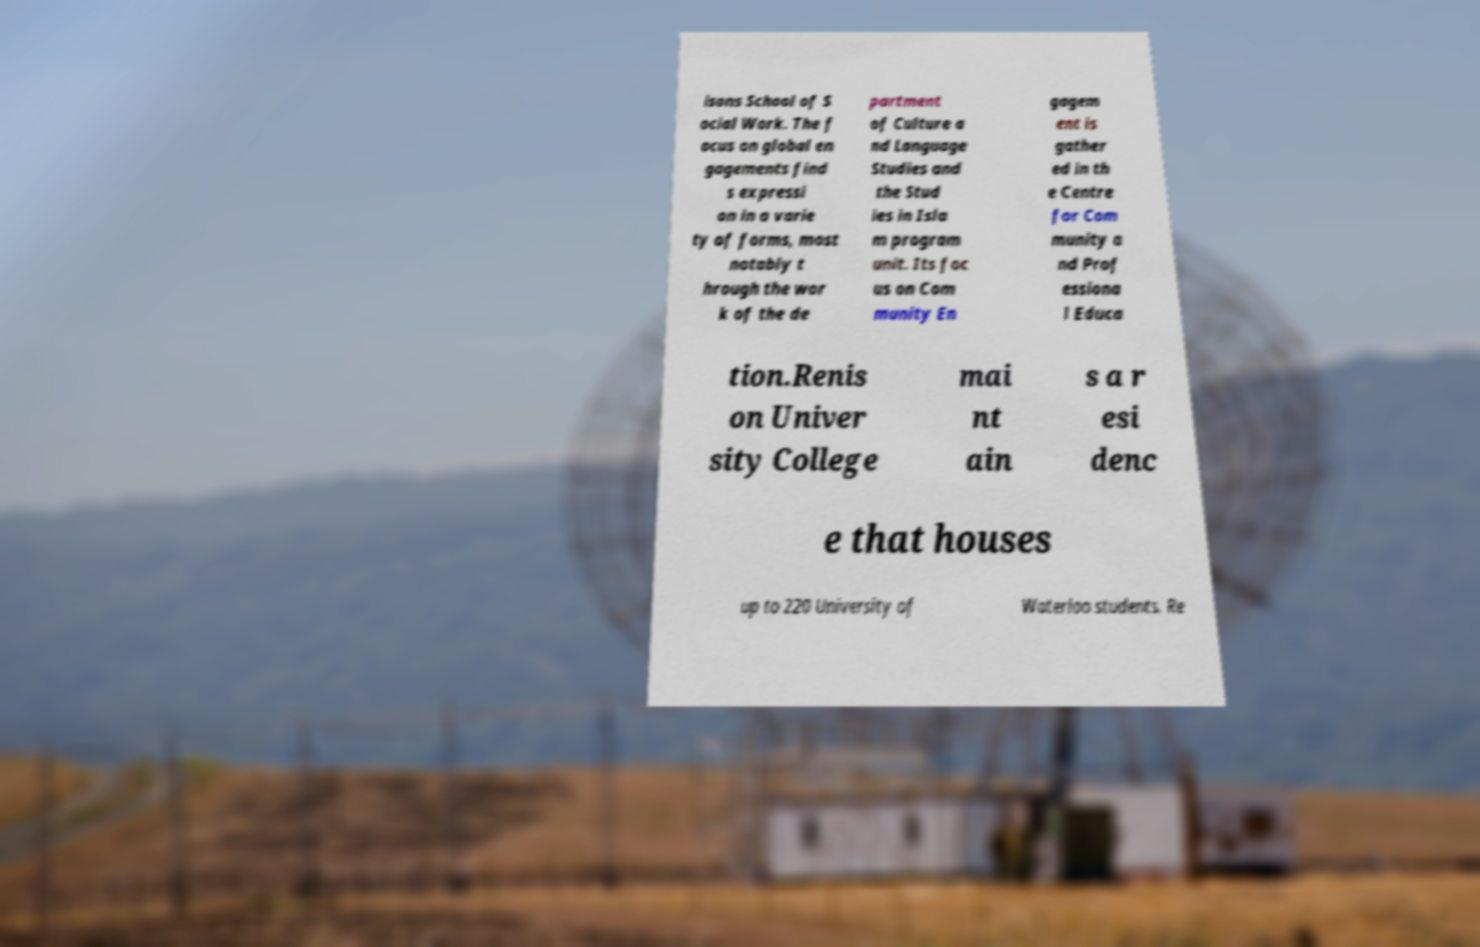There's text embedded in this image that I need extracted. Can you transcribe it verbatim? isons School of S ocial Work. The f ocus on global en gagements find s expressi on in a varie ty of forms, most notably t hrough the wor k of the de partment of Culture a nd Language Studies and the Stud ies in Isla m program unit. Its foc us on Com munity En gagem ent is gather ed in th e Centre for Com munity a nd Prof essiona l Educa tion.Renis on Univer sity College mai nt ain s a r esi denc e that houses up to 220 University of Waterloo students. Re 